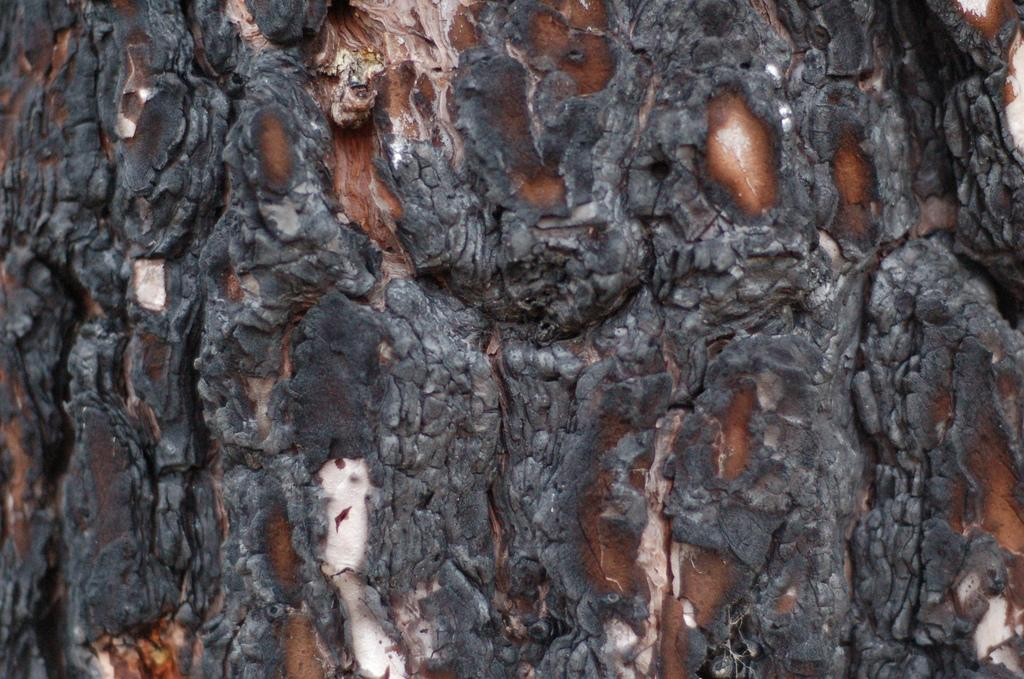What is the main subject of the image? The main subject of the image is a tree trunk. Can you describe the tree trunk in the image? The tree trunk appears to be a large, solid structure in the image. What type of patch can be seen on the snake in the image? There is no snake or patch present in the image; it only features a tree trunk. 